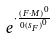<formula> <loc_0><loc_0><loc_500><loc_500>e ^ { \cdot \frac { ( F \cdot M ) ^ { 0 } } { 0 { ( s _ { F } ) } ^ { 0 } } }</formula> 